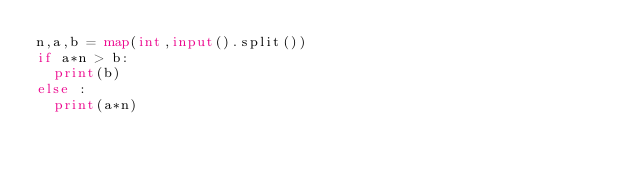Convert code to text. <code><loc_0><loc_0><loc_500><loc_500><_Python_>n,a,b = map(int,input().split())
if a*n > b:
	print(b)
else :
	print(a*n)</code> 